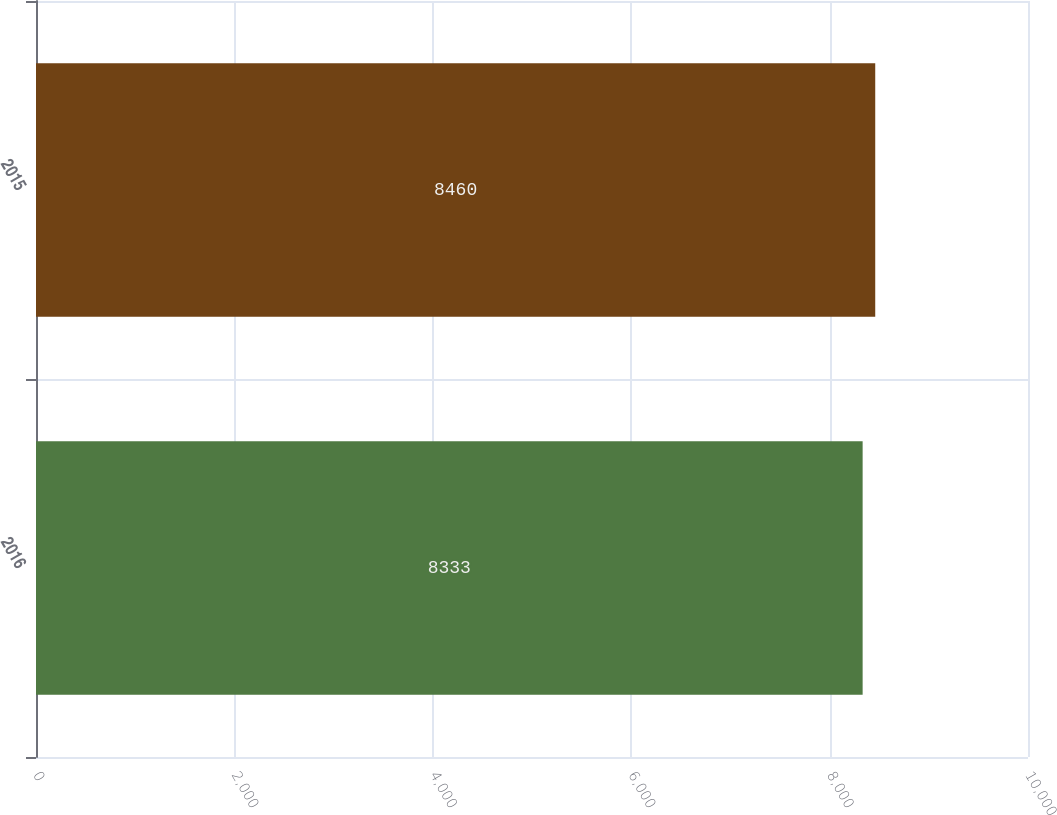Convert chart. <chart><loc_0><loc_0><loc_500><loc_500><bar_chart><fcel>2016<fcel>2015<nl><fcel>8333<fcel>8460<nl></chart> 